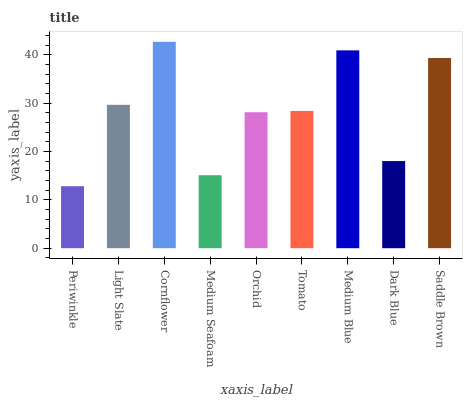Is Light Slate the minimum?
Answer yes or no. No. Is Light Slate the maximum?
Answer yes or no. No. Is Light Slate greater than Periwinkle?
Answer yes or no. Yes. Is Periwinkle less than Light Slate?
Answer yes or no. Yes. Is Periwinkle greater than Light Slate?
Answer yes or no. No. Is Light Slate less than Periwinkle?
Answer yes or no. No. Is Tomato the high median?
Answer yes or no. Yes. Is Tomato the low median?
Answer yes or no. Yes. Is Medium Seafoam the high median?
Answer yes or no. No. Is Saddle Brown the low median?
Answer yes or no. No. 